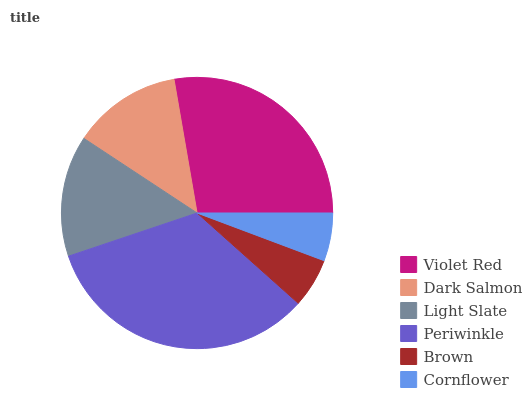Is Cornflower the minimum?
Answer yes or no. Yes. Is Periwinkle the maximum?
Answer yes or no. Yes. Is Dark Salmon the minimum?
Answer yes or no. No. Is Dark Salmon the maximum?
Answer yes or no. No. Is Violet Red greater than Dark Salmon?
Answer yes or no. Yes. Is Dark Salmon less than Violet Red?
Answer yes or no. Yes. Is Dark Salmon greater than Violet Red?
Answer yes or no. No. Is Violet Red less than Dark Salmon?
Answer yes or no. No. Is Light Slate the high median?
Answer yes or no. Yes. Is Dark Salmon the low median?
Answer yes or no. Yes. Is Periwinkle the high median?
Answer yes or no. No. Is Brown the low median?
Answer yes or no. No. 